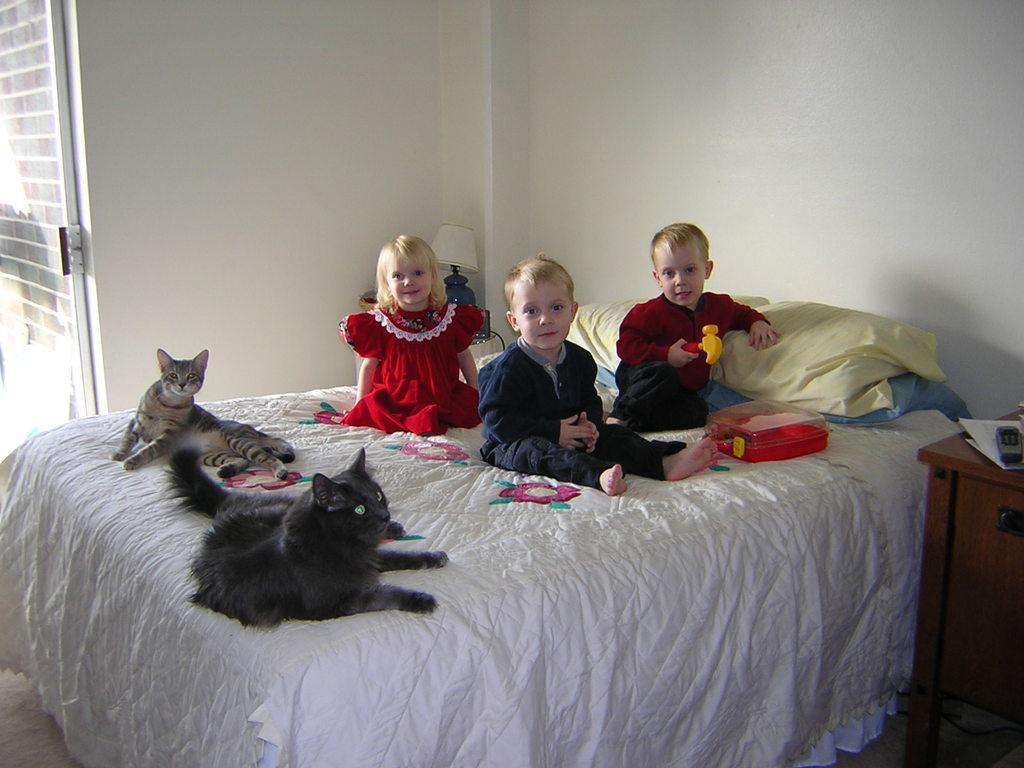Could you give a brief overview of what you see in this image? The picture is taken in a closed room in which one big bed is present on that there are two cats and three children and one box, pillows are present. One girl is in red dress and one boy is in red shirt and pant and another boy is in blue dress, behind them there is bed lamp and a big wall and beside the bed there is a table on which remote and papers present and there is a door opened. 